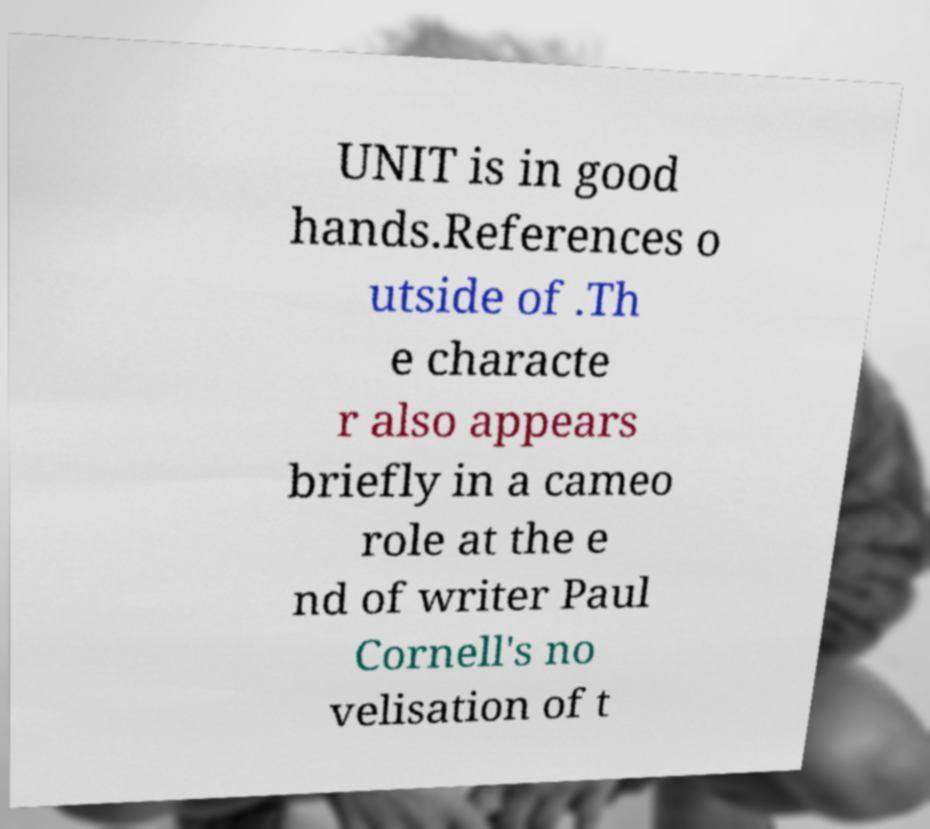Please identify and transcribe the text found in this image. UNIT is in good hands.References o utside of .Th e characte r also appears briefly in a cameo role at the e nd of writer Paul Cornell's no velisation of t 